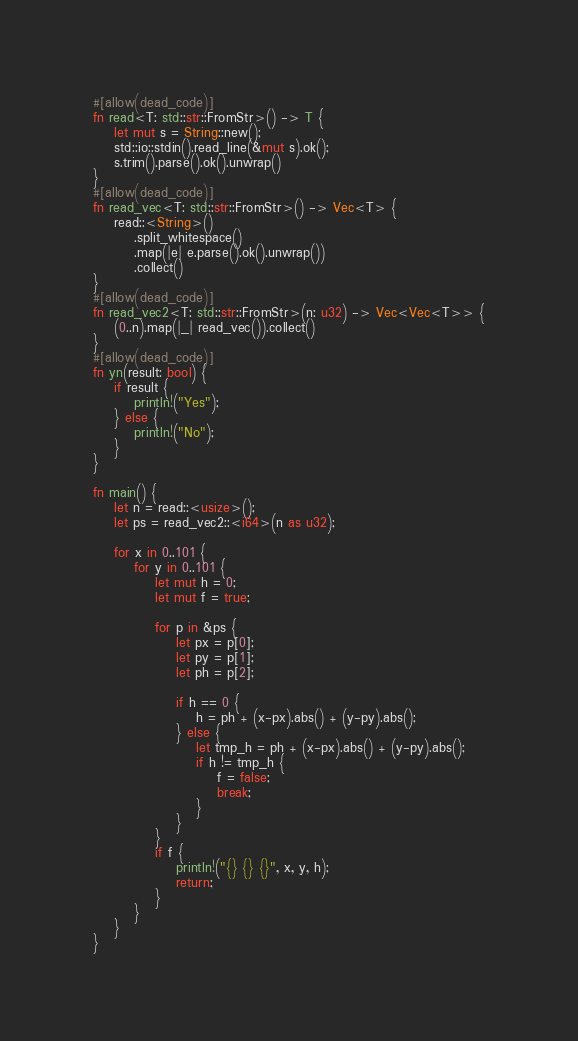<code> <loc_0><loc_0><loc_500><loc_500><_Rust_>#[allow(dead_code)]
fn read<T: std::str::FromStr>() -> T {
    let mut s = String::new();
    std::io::stdin().read_line(&mut s).ok();
    s.trim().parse().ok().unwrap()
}
#[allow(dead_code)]
fn read_vec<T: std::str::FromStr>() -> Vec<T> {
    read::<String>()
        .split_whitespace()
        .map(|e| e.parse().ok().unwrap())
        .collect()
}
#[allow(dead_code)]
fn read_vec2<T: std::str::FromStr>(n: u32) -> Vec<Vec<T>> {
    (0..n).map(|_| read_vec()).collect()
}
#[allow(dead_code)]
fn yn(result: bool) {
    if result {
        println!("Yes");
    } else {
        println!("No");
    }
}

fn main() {
    let n = read::<usize>();
    let ps = read_vec2::<i64>(n as u32);

    for x in 0..101 {
        for y in 0..101 {
            let mut h = 0;
            let mut f = true;

            for p in &ps {
                let px = p[0];
                let py = p[1];
                let ph = p[2];

                if h == 0 {
                    h = ph + (x-px).abs() + (y-py).abs();
                } else {
                    let tmp_h = ph + (x-px).abs() + (y-py).abs();
                    if h != tmp_h {
                        f = false;
                        break;
                    }
                }
            }
            if f {
                println!("{} {} {}", x, y, h);
                return;
            }
        }
    }
}
</code> 